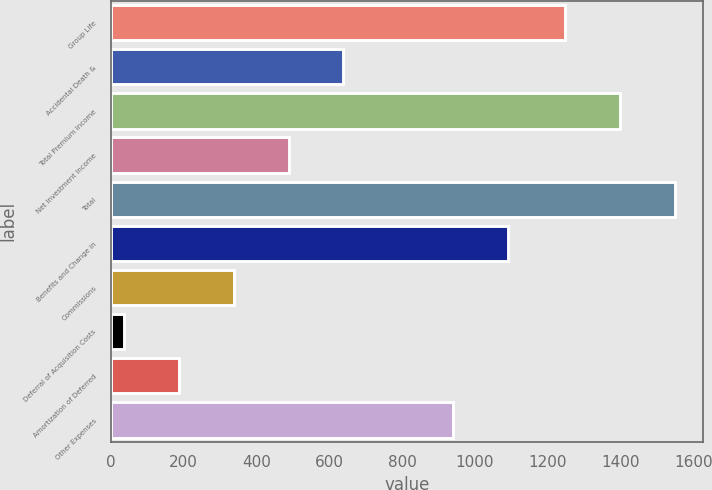Convert chart. <chart><loc_0><loc_0><loc_500><loc_500><bar_chart><fcel>Group Life<fcel>Accidental Death &<fcel>Total Premium Income<fcel>Net Investment Income<fcel>Total<fcel>Benefits and Change in<fcel>Commissions<fcel>Deferral of Acquisition Costs<fcel>Amortization of Deferred<fcel>Other Expenses<nl><fcel>1248.1<fcel>639.02<fcel>1399.7<fcel>488.69<fcel>1550.03<fcel>1090.01<fcel>338.36<fcel>37.7<fcel>188.03<fcel>939.68<nl></chart> 